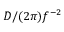Convert formula to latex. <formula><loc_0><loc_0><loc_500><loc_500>D / ( 2 \pi ) f ^ { - 2 }</formula> 